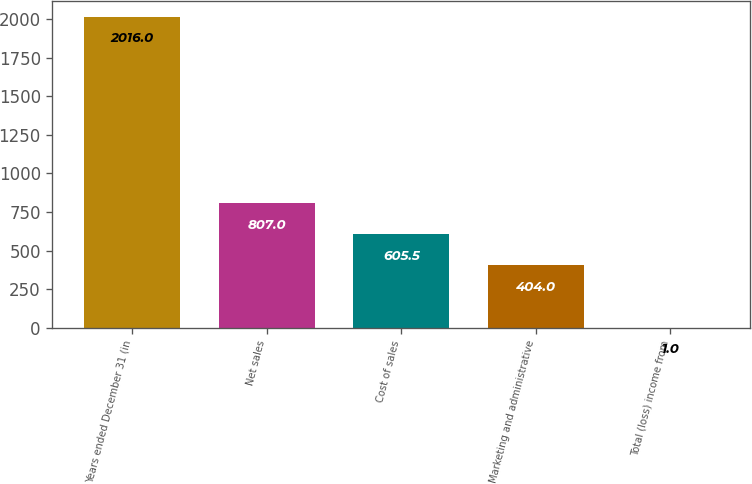<chart> <loc_0><loc_0><loc_500><loc_500><bar_chart><fcel>Years ended December 31 (in<fcel>Net sales<fcel>Cost of sales<fcel>Marketing and administrative<fcel>Total (loss) income from<nl><fcel>2016<fcel>807<fcel>605.5<fcel>404<fcel>1<nl></chart> 